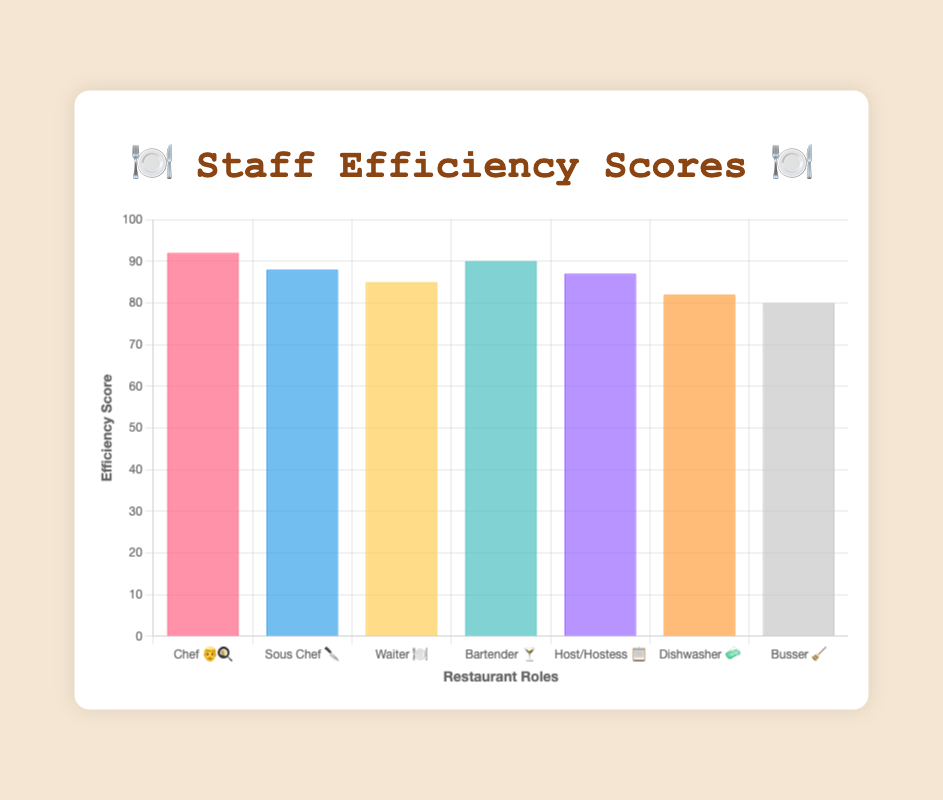How many staff roles are displayed in the chart? The chart displays the efficiency scores of different staff roles, with each bar representing one role. By counting the bars, you can determine the total number.
Answer: 7 Which role has the highest efficiency score? The role with the highest bar in the chart represents the highest efficiency score. The Chef 👨‍🍳 has the highest bar.
Answer: Chef 👨‍🍳 What is the efficiency score of the Dishwasher 🧼? Find the bar labeled Dishwasher 🧼 and refer to the y-axis value to determine the efficiency score.
Answer: 82 What is the average efficiency score of all the roles? Add all the efficiency scores (92 + 88 + 85 + 90 + 87 + 82 + 80) and divide by the number of roles (7). (92 + 88 + 85 + 90 + 87 + 82 + 80) / 7 = 604 / 7
Answer: 86.29 Which role has a lower efficiency score: the Busser 🧹 or the Host/Hostess 📋? Compare the height of the bars for the Busser 🧹 and the Host/Hostess 📋. The Busser 🧹 has a lower bar than the Host/Hostess 📋.
Answer: Busser 🧹 What is the difference between the efficiency scores of the Chef 👨‍🍳 and the Sous Chef 🔪? Subtract the Sous Chef 🔪 efficiency score from the Chef 👨‍🍳 efficiency score: 92 - 88.
Answer: 4 Which role has the third-highest efficiency score? Rank the efficiency scores from highest to lowest. The third-highest score corresponds to the Waiter 🍽️ with an efficiency score of 85.
Answer: Waiter 🍽️ What is the sum of the efficiency scores of the Bartender 🍸 and the Chef 👨‍🍳? Add the efficiency scores of the Bartender 🍸 and the Chef 👨‍🍳: 90 + 92.
Answer: 182 Are there any roles with an efficiency score below 85? Look for bars where the efficiency score is below 85. The Dishwasher 🧼 and the Busser 🧹 both have scores below 85.
Answer: Yes What color represents the efficiency score of the Waiter 🍽️ in the chart? Identify the color of the bar associated with the Waiter 🍽️. The chart uses specific colors to depict each role. The Waiter's bar is yellow.
Answer: Yellow 